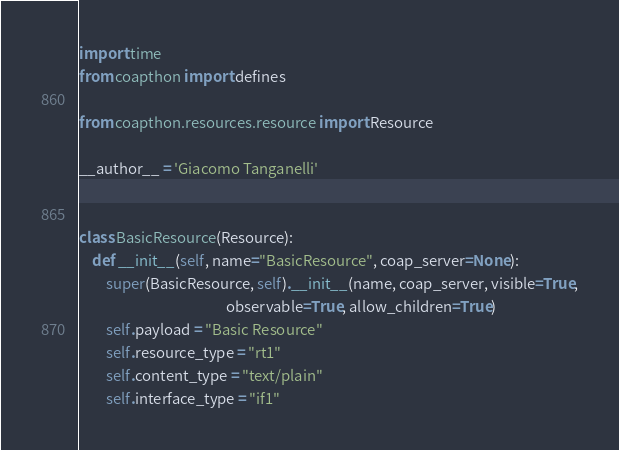<code> <loc_0><loc_0><loc_500><loc_500><_Python_>import time
from coapthon import defines

from coapthon.resources.resource import Resource

__author__ = 'Giacomo Tanganelli'


class BasicResource(Resource):
    def __init__(self, name="BasicResource", coap_server=None):
        super(BasicResource, self).__init__(name, coap_server, visible=True,
                                            observable=True, allow_children=True)
        self.payload = "Basic Resource"
        self.resource_type = "rt1"
        self.content_type = "text/plain"
        self.interface_type = "if1"
</code> 